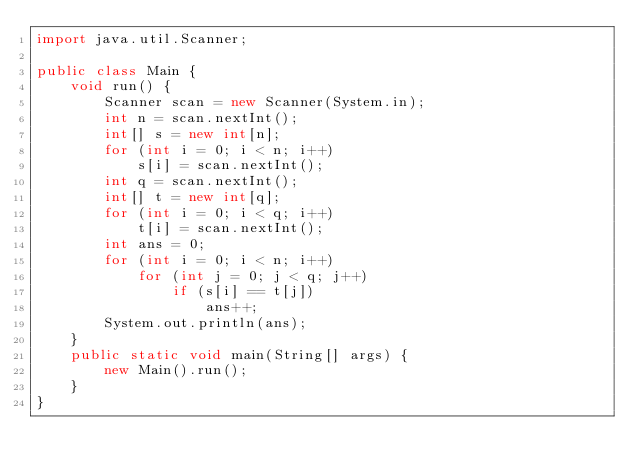<code> <loc_0><loc_0><loc_500><loc_500><_Java_>import java.util.Scanner;

public class Main {
	void run() {
		Scanner scan = new Scanner(System.in);
		int n = scan.nextInt();
		int[] s = new int[n];
		for (int i = 0; i < n; i++)
			s[i] = scan.nextInt();
		int q = scan.nextInt();
		int[] t = new int[q];
		for (int i = 0; i < q; i++)
			t[i] = scan.nextInt();
		int ans = 0;
		for (int i = 0; i < n; i++)
			for (int j = 0; j < q; j++)
				if (s[i] == t[j])
					ans++;
		System.out.println(ans);
	}
	public static void main(String[] args) {
		new Main().run();
	}
}

</code> 